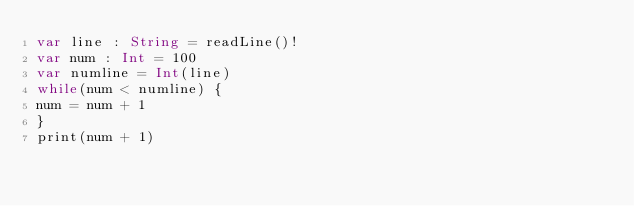Convert code to text. <code><loc_0><loc_0><loc_500><loc_500><_Swift_>var line : String = readLine()!
var num : Int = 100
var numline = Int(line)
while(num < numline) {
num = num + 1
}
print(num + 1)
</code> 